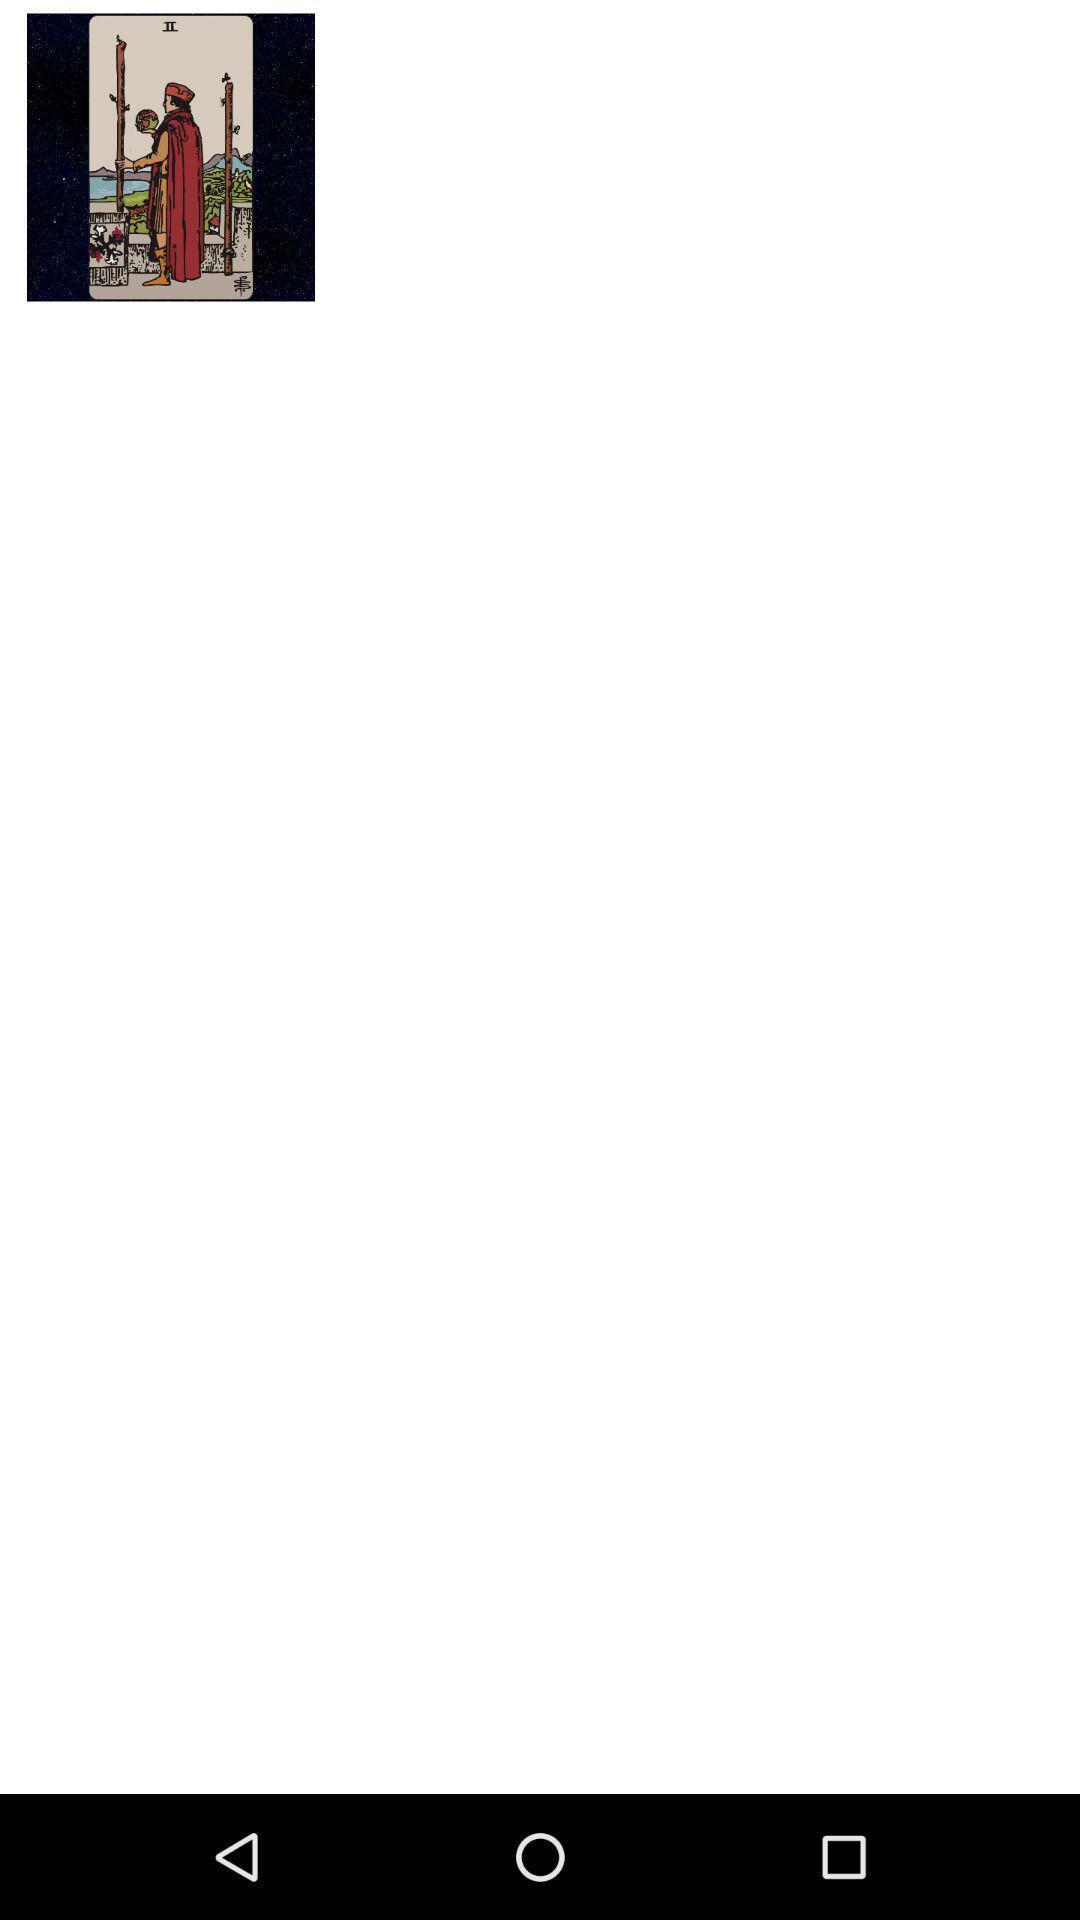Describe this image in words. Picture in the mobile with back option. 